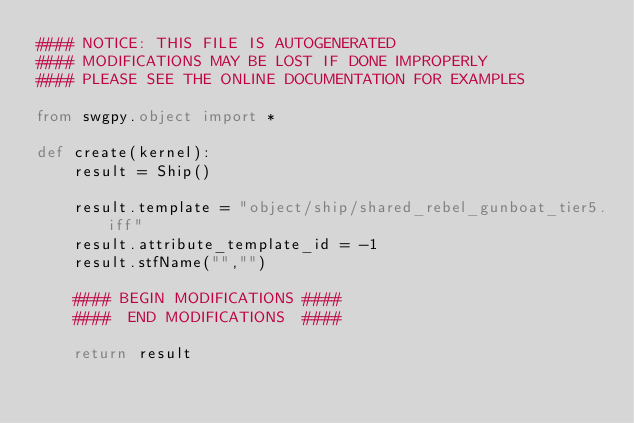Convert code to text. <code><loc_0><loc_0><loc_500><loc_500><_Python_>#### NOTICE: THIS FILE IS AUTOGENERATED
#### MODIFICATIONS MAY BE LOST IF DONE IMPROPERLY
#### PLEASE SEE THE ONLINE DOCUMENTATION FOR EXAMPLES

from swgpy.object import *	

def create(kernel):
	result = Ship()

	result.template = "object/ship/shared_rebel_gunboat_tier5.iff"
	result.attribute_template_id = -1
	result.stfName("","")		
	
	#### BEGIN MODIFICATIONS ####
	####  END MODIFICATIONS  ####
	
	return result</code> 